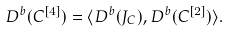<formula> <loc_0><loc_0><loc_500><loc_500>D ^ { b } ( C ^ { [ 4 ] } ) = \langle D ^ { b } ( J _ { C } ) , D ^ { b } ( C ^ { [ 2 ] } ) \rangle .</formula> 